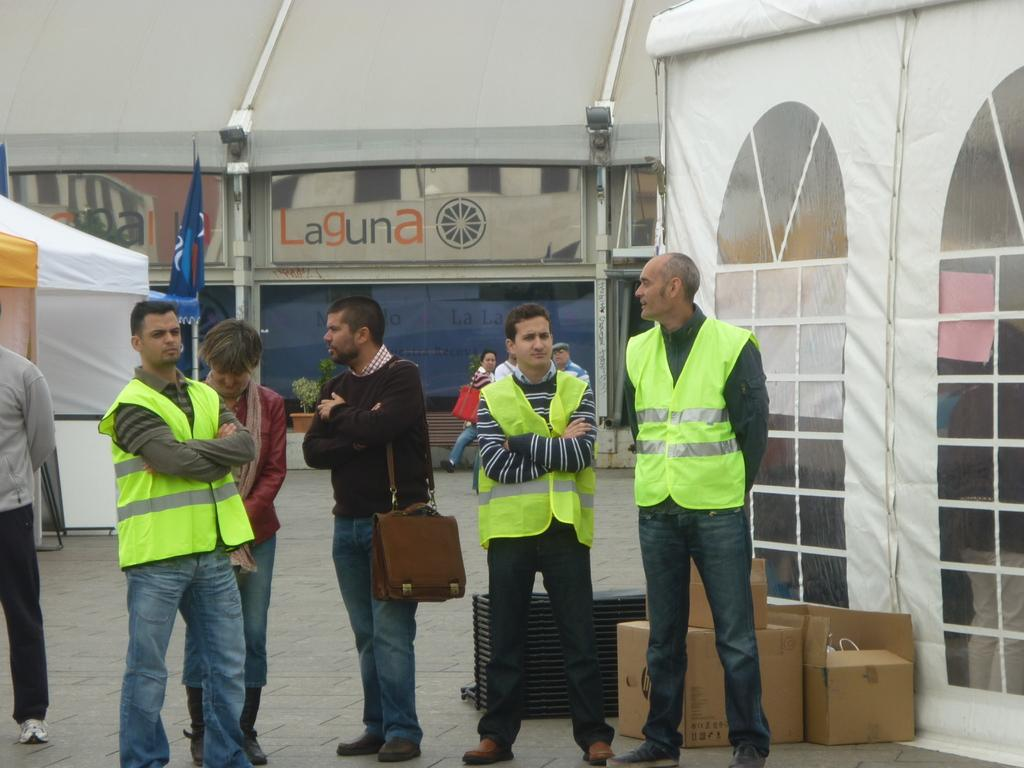What are the people in the image doing? The people in the image are standing in the center. Can you describe the man standing in the center? The man standing in the center is wearing a bag. What can be seen in the background of the image? There are tents and flags in the background of the image. What objects are at the bottom of the image? There are boxes at the bottom of the image. What type of skirt is the man wearing in the image? The man in the image is not wearing a skirt; he is wearing a bag. What is the smell like in the image? There is no information about the smell in the image, as it is a visual medium. 